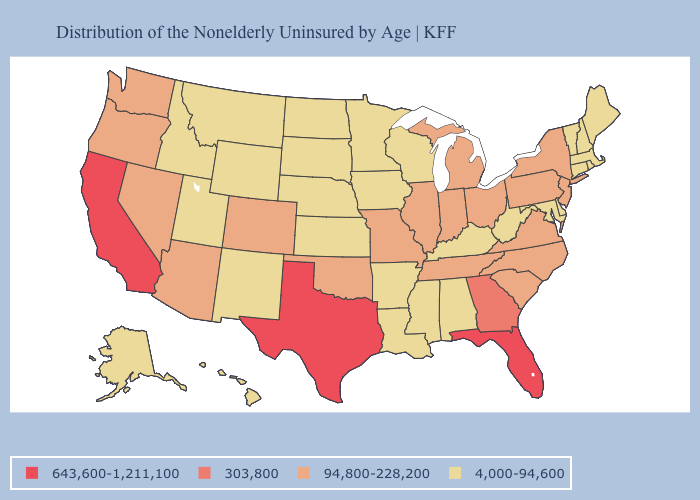What is the lowest value in the Northeast?
Keep it brief. 4,000-94,600. Which states have the lowest value in the West?
Short answer required. Alaska, Hawaii, Idaho, Montana, New Mexico, Utah, Wyoming. Among the states that border Mississippi , does Alabama have the lowest value?
Quick response, please. Yes. How many symbols are there in the legend?
Short answer required. 4. Does the first symbol in the legend represent the smallest category?
Be succinct. No. Name the states that have a value in the range 4,000-94,600?
Give a very brief answer. Alabama, Alaska, Arkansas, Connecticut, Delaware, Hawaii, Idaho, Iowa, Kansas, Kentucky, Louisiana, Maine, Maryland, Massachusetts, Minnesota, Mississippi, Montana, Nebraska, New Hampshire, New Mexico, North Dakota, Rhode Island, South Dakota, Utah, Vermont, West Virginia, Wisconsin, Wyoming. What is the value of Alaska?
Be succinct. 4,000-94,600. Name the states that have a value in the range 643,600-1,211,100?
Keep it brief. California, Florida, Texas. Among the states that border Delaware , does Maryland have the lowest value?
Short answer required. Yes. Is the legend a continuous bar?
Quick response, please. No. Which states hav the highest value in the Northeast?
Keep it brief. New Jersey, New York, Pennsylvania. Does Illinois have the lowest value in the MidWest?
Answer briefly. No. Name the states that have a value in the range 643,600-1,211,100?
Concise answer only. California, Florida, Texas. Name the states that have a value in the range 303,800?
Short answer required. Georgia. Name the states that have a value in the range 4,000-94,600?
Be succinct. Alabama, Alaska, Arkansas, Connecticut, Delaware, Hawaii, Idaho, Iowa, Kansas, Kentucky, Louisiana, Maine, Maryland, Massachusetts, Minnesota, Mississippi, Montana, Nebraska, New Hampshire, New Mexico, North Dakota, Rhode Island, South Dakota, Utah, Vermont, West Virginia, Wisconsin, Wyoming. 